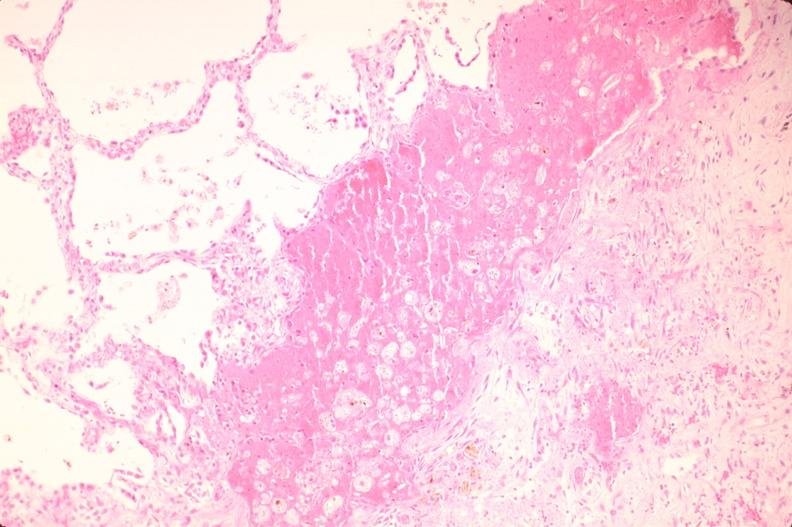does this image show lung, infarct, acute and organized?
Answer the question using a single word or phrase. Yes 